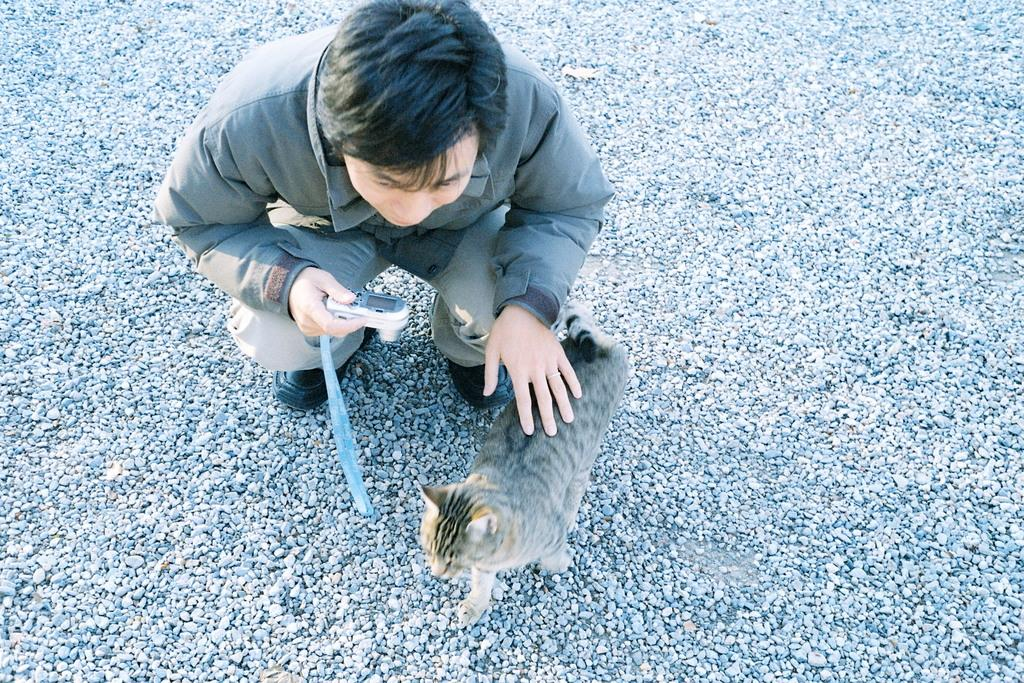What is the man in the image holding? The man is holding a camera with his hand. What else can be seen in the image besides the man and the camera? There is: There is a cat in the image. Where is the cat located in the image? The cat is on the ground. How does the cat appear to be in the image? The cat appears to be stoned, possibly lying down or resting. What type of acoustics can be heard coming from the giraffe in the image? There is no giraffe present in the image, so it is not possible to determine the acoustics coming from it. 